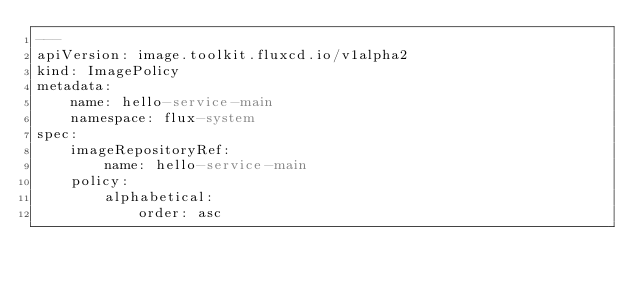<code> <loc_0><loc_0><loc_500><loc_500><_YAML_>---
apiVersion: image.toolkit.fluxcd.io/v1alpha2
kind: ImagePolicy
metadata:
    name: hello-service-main
    namespace: flux-system
spec:
    imageRepositoryRef:
        name: hello-service-main
    policy:
        alphabetical:
            order: asc
</code> 